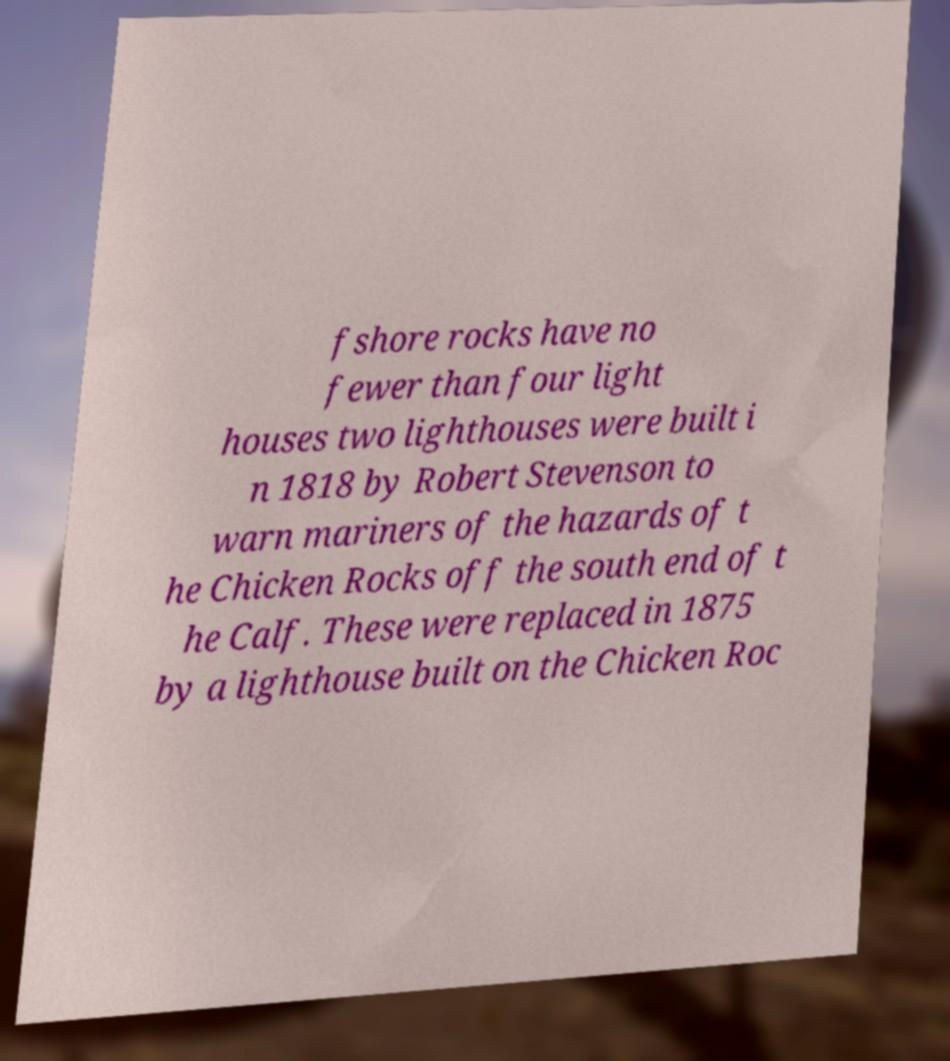Can you read and provide the text displayed in the image?This photo seems to have some interesting text. Can you extract and type it out for me? fshore rocks have no fewer than four light houses two lighthouses were built i n 1818 by Robert Stevenson to warn mariners of the hazards of t he Chicken Rocks off the south end of t he Calf. These were replaced in 1875 by a lighthouse built on the Chicken Roc 